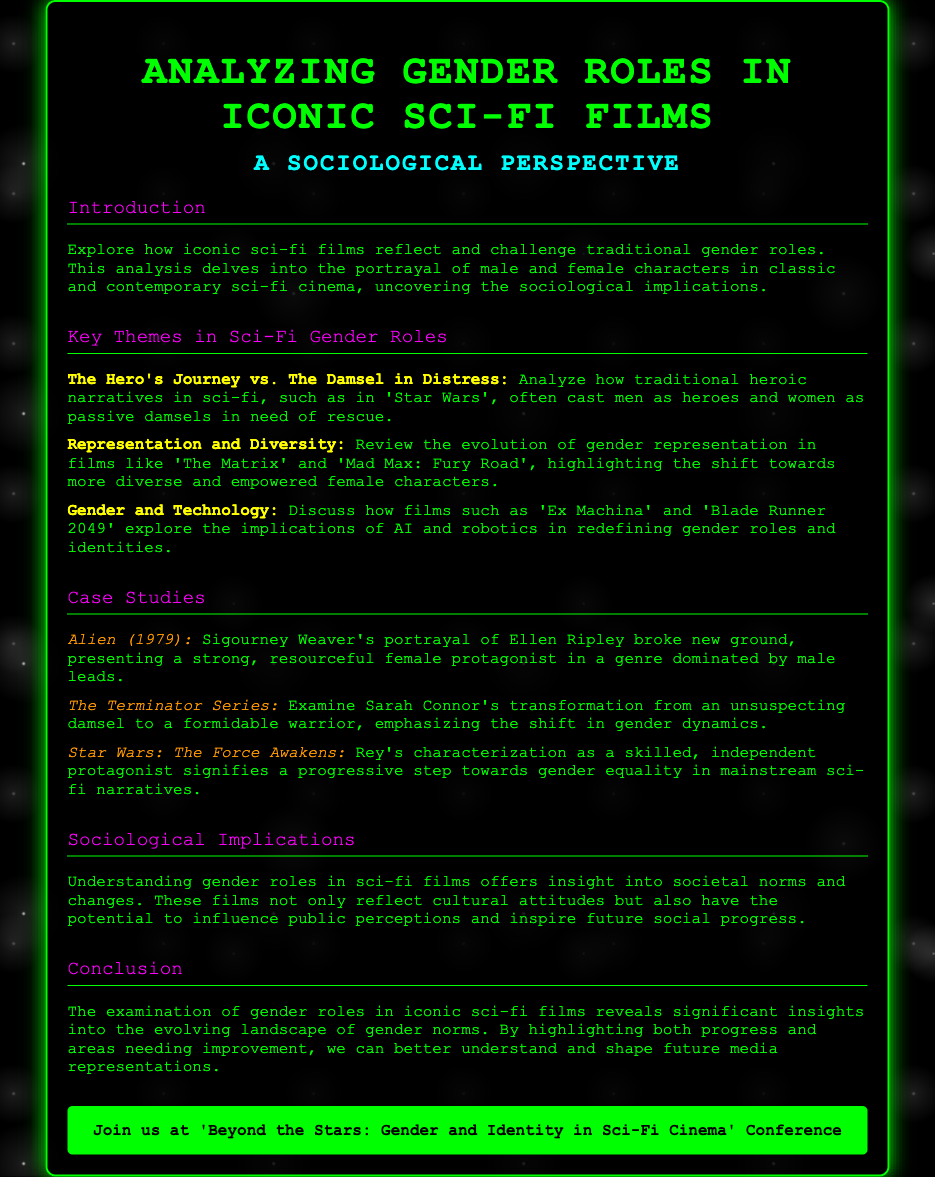what is the title of the document? The title of the document is presented at the top of the advertisement.
Answer: Analyzing Gender Roles in Iconic Sci-Fi Films what is the main focus of the analysis? The document outlines what the analysis seeks to uncover about gender roles in films.
Answer: Gender roles in iconic sci-fi films which film features a strong female protagonist, Ellen Ripley? This information is provided in the case studies section of the document.
Answer: Alien (1979) what key theme explores traditional heroic narratives? The document lists key themes that reflect on gender roles in sci-fi films.
Answer: The Hero's Journey vs. The Damsel in Distress which film's female character is Rey? The document mentions Rey as a character in a specific sci-fi film as part of gender role analysis.
Answer: Star Wars: The Force Awakens how does the document describe the sociological implications of sci-fi films? The document provides insight into what understanding gender roles in sci-fi films can offer.
Answer: Insight into societal norms and changes what is the color of the call-to-action button? The document's design elements specify colors related to the call-to-action.
Answer: Green what conference is mentioned in the document? The document highlights an event where further discussions on the subject will take place.
Answer: Beyond the Stars: Gender and Identity in Sci-Fi Cinema 